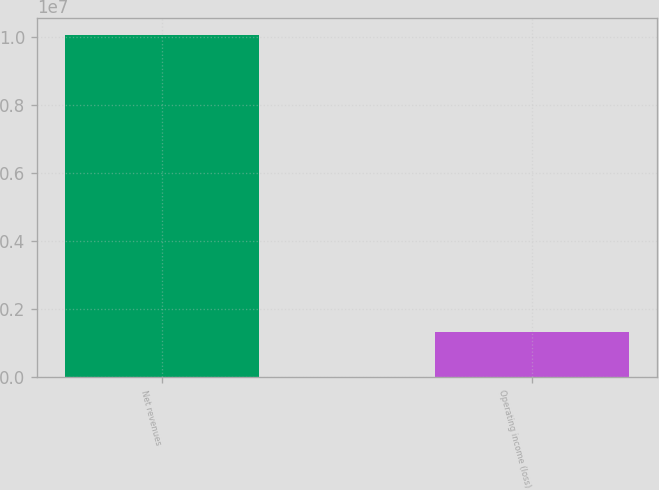<chart> <loc_0><loc_0><loc_500><loc_500><bar_chart><fcel>Net revenues<fcel>Operating income (loss)<nl><fcel>1.0082e+07<fcel>1.32354e+06<nl></chart> 